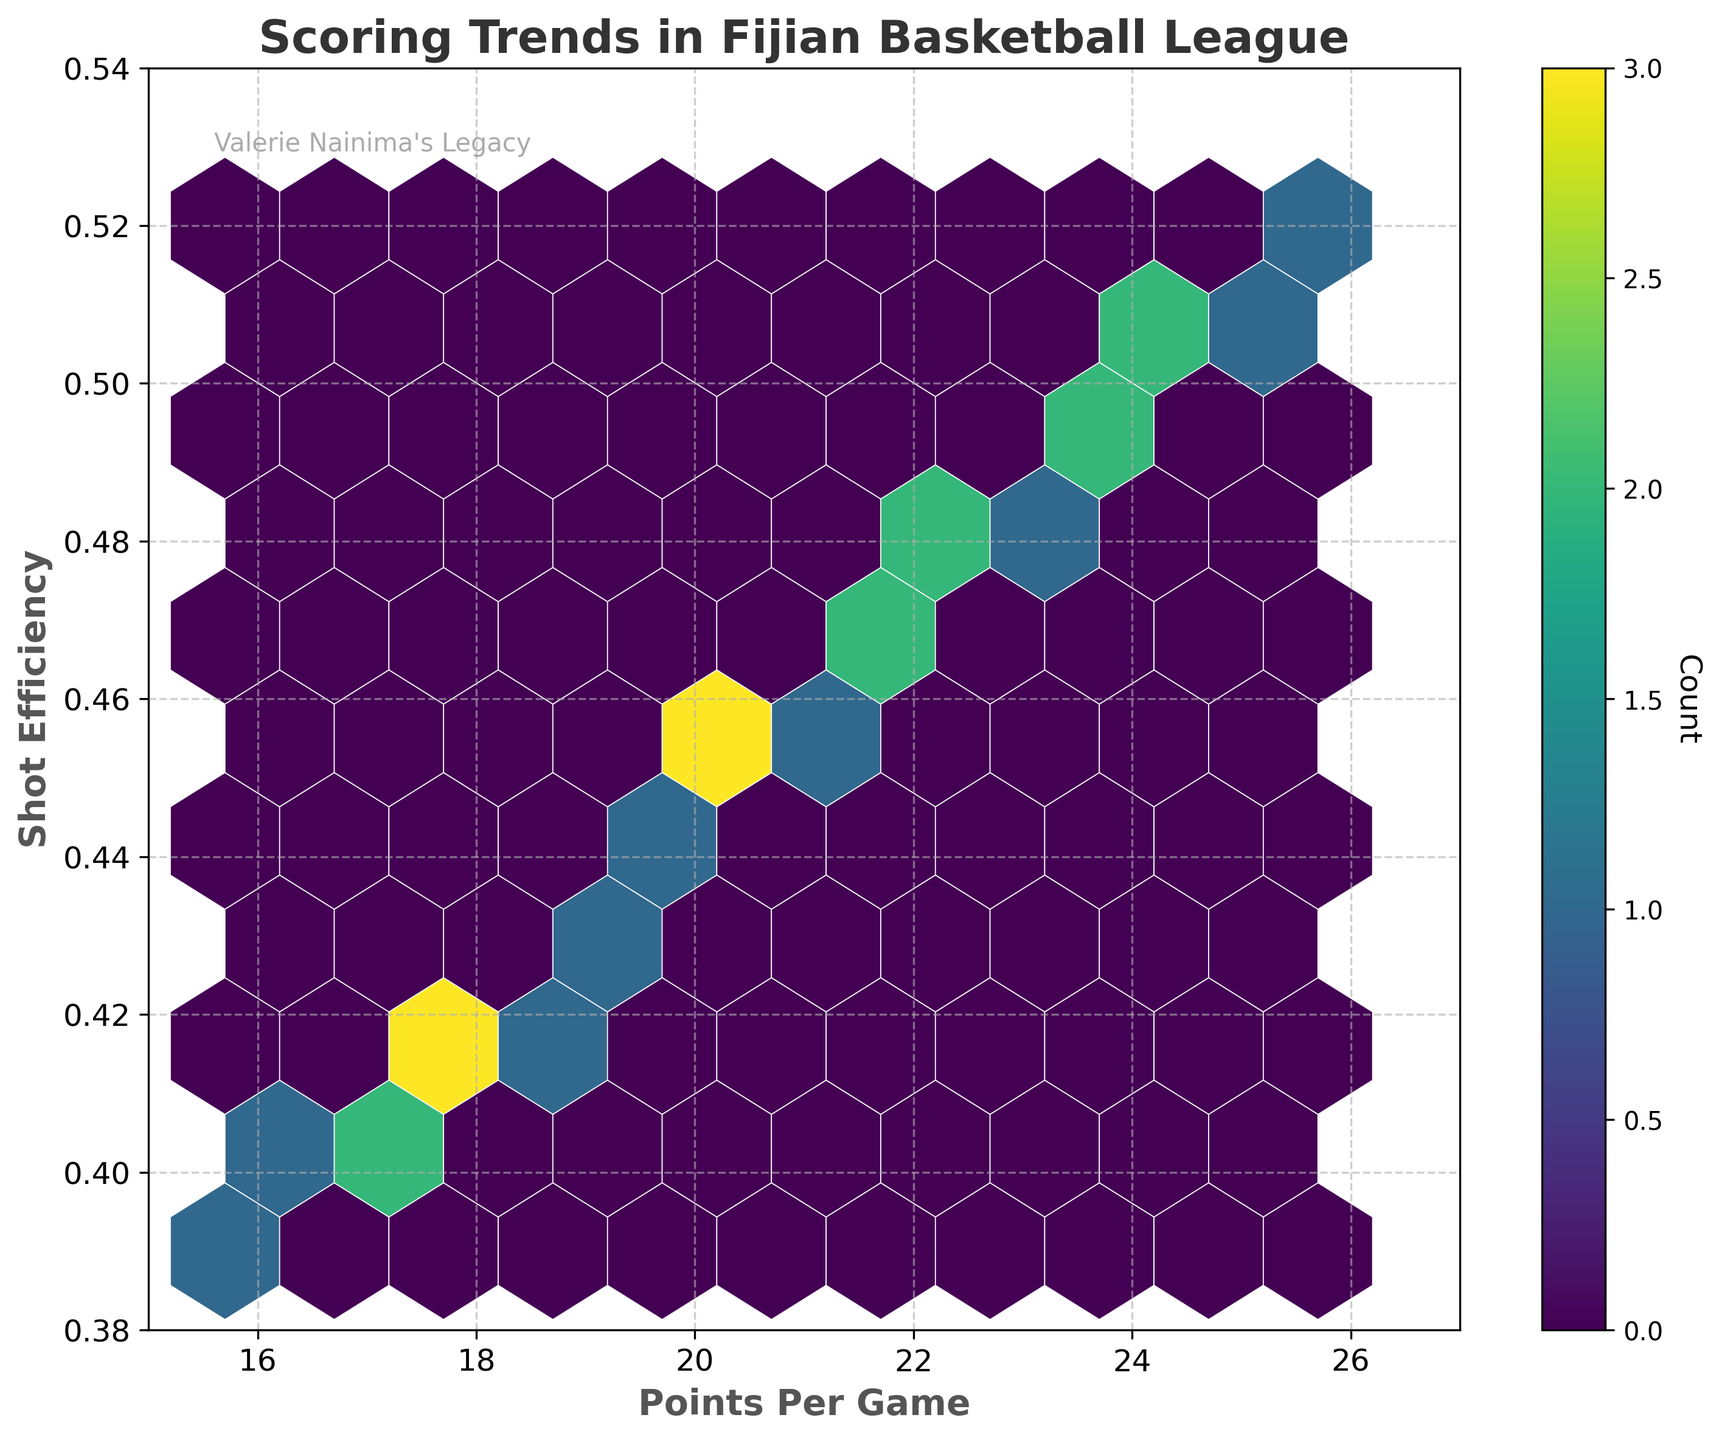What is the title of the hexbin plot? Look at the text at the top of the figure to find the title. The title is typically bold and larger than other text.
Answer: Scoring Trends in Fijian Basketball League What are the x and y-axis labels? Look for the text adjacent to the x and y axes to identify the labels. They describe what each axis represents.
Answer: Points Per Game and Shot Efficiency What is the grid size used for the hexbin? The number of hex bins along one axis determines the grid size. You can visually count the number of hex bins along an axis or refer to the legend explanation if present.
Answer: 10 What does the color of the hex bins represent? Identify the color bar or legend attached to the plot which explains the meaning of the colors. The gradient usually indicates a variable like count.
Answer: Count What is the range of Points Per Game displayed on the x-axis? Check the values at the minimum and maximum ends of the x-axis. The range is determined by these two values.
Answer: 15 to 27 Which area has the highest concentration of data points based on the hexbin color intensity? Look for the area with the densest color, indicating the highest number of data points within that region. This is usually represented by a darker or more vibrant color.
Answer: Around (22, 0.48) What text is written in the top-left part of the plot? Find the text placed inside the plot area, usually in a smaller font and a lighter color for annotations or additional notes.
Answer: Valerie Nainima's Legacy How does the shot efficiency generally change as points per game increase? Observe the overall direction or trend of the hexbin clusters from left to right along the plot. If the clusters show a positive slope, shot efficiency increases with points per game and vice versa.
Answer: Increases How many main clusters of data are visible? Count the distinct and visually separable clusters of hex bins within the plot. This shows grouping patterns in the data.
Answer: 4 What is the range of shot efficiency displayed on the y-axis? Check the values at the minimum and maximum ends of the y-axis. The range is between these two values.
Answer: 0.38 to 0.54 